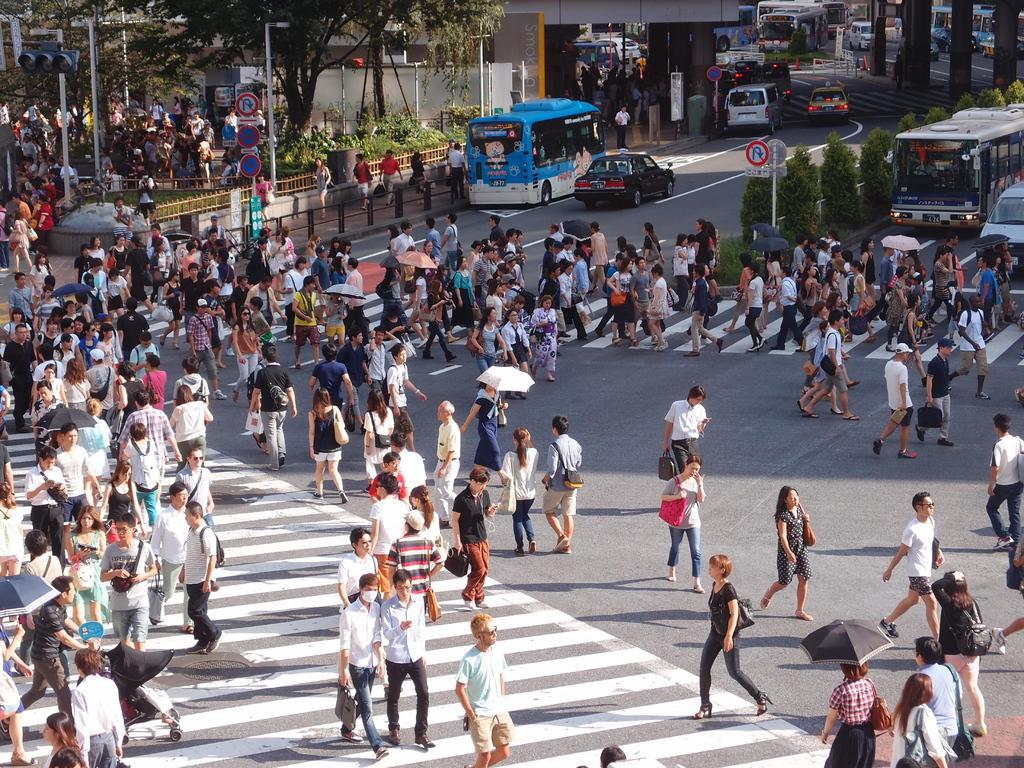Could you give a brief overview of what you see in this image? In the middle of the image few people are walking on the road. Behind them there are some trees and poles and sign boards and fencing. At the top of the image there are some vehicles on the road and there are some trees. 